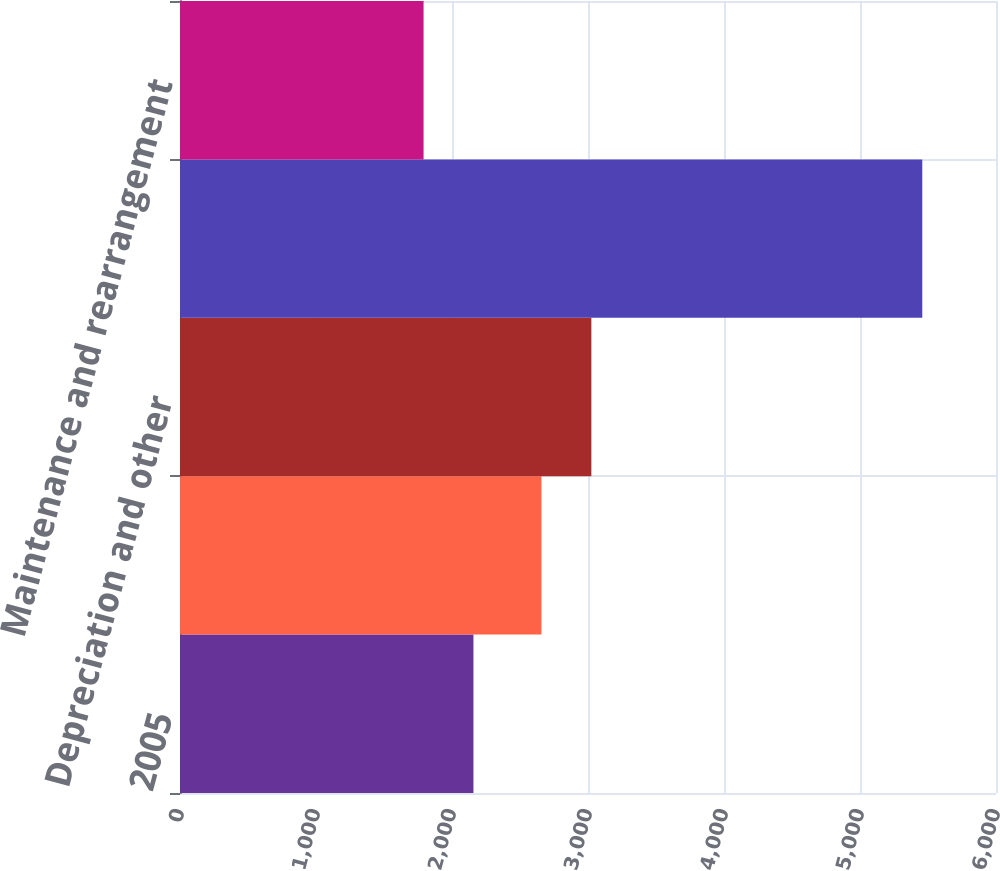Convert chart. <chart><loc_0><loc_0><loc_500><loc_500><bar_chart><fcel>2005<fcel>Amortization of special tools<fcel>Depreciation and other<fcel>Total 8133<fcel>Maintenance and rearrangement<nl><fcel>2157.7<fcel>2658<fcel>3024.7<fcel>5458<fcel>1791<nl></chart> 